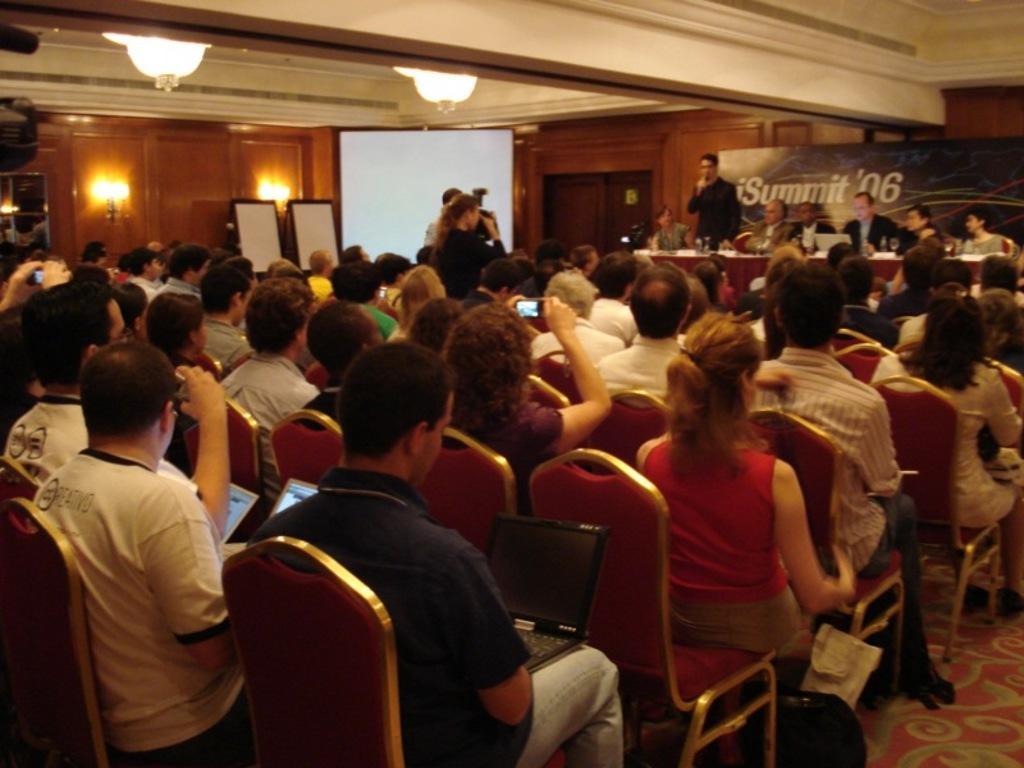Could you give a brief overview of what you see in this image? In this picture there are group of people those who are sitting on the chairs at the left side of the image and there is a projector screen at the left side of the image and there is a stage at the right side of the image and there are some people those who are taking the videos at the left side of the image. 